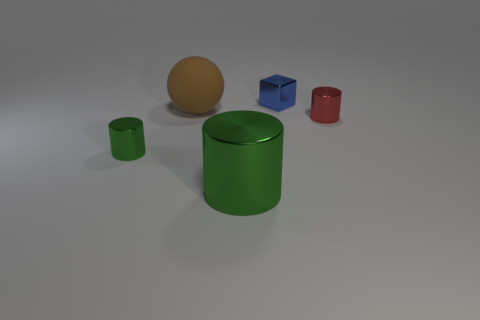There is a shiny cube that is the same size as the red shiny object; what is its color? The shiny cube that matches the red object in size is blue, offering a stark color contrast to its red counterpart while mirroring its reflective surface. 